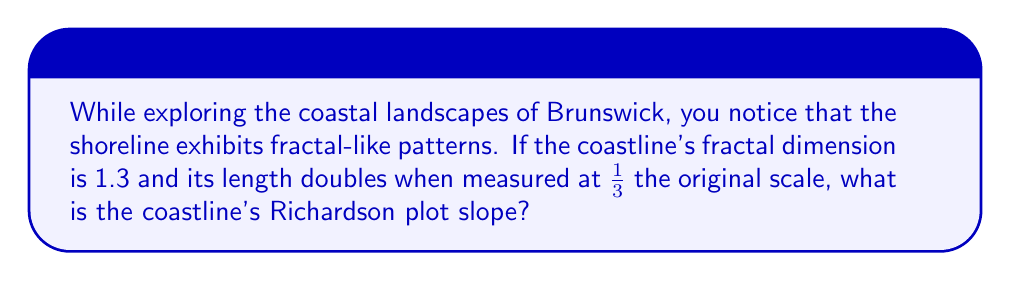What is the answer to this math problem? Let's approach this step-by-step:

1) The fractal dimension (D) is related to the Richardson plot slope (m) by the equation:

   $D = 1 - m$

2) We're given that $D = 1.3$, so we can substitute this:

   $1.3 = 1 - m$

3) Solving for m:

   $m = 1 - 1.3 = -0.3$

4) We can verify this using the given information about the coastline length doubling when measured at 1/3 the original scale.

5) The general form of the Richardson plot equation is:

   $L(ε) = kε^m$

   Where $L(ε)$ is the measured length at scale $ε$, $k$ is a constant, and $m$ is the slope.

6) If the length doubles when the scale is 1/3, we can write:

   $2 = (\frac{1}{3})^m$

7) Taking the logarithm of both sides:

   $\log(2) = m \log(\frac{1}{3})$

8) Solving for m:

   $m = \frac{\log(2)}{\log(\frac{1}{3})} = \frac{\log(2)}{-\log(3)} \approx -0.3$

This confirms our earlier calculation.
Answer: -0.3 